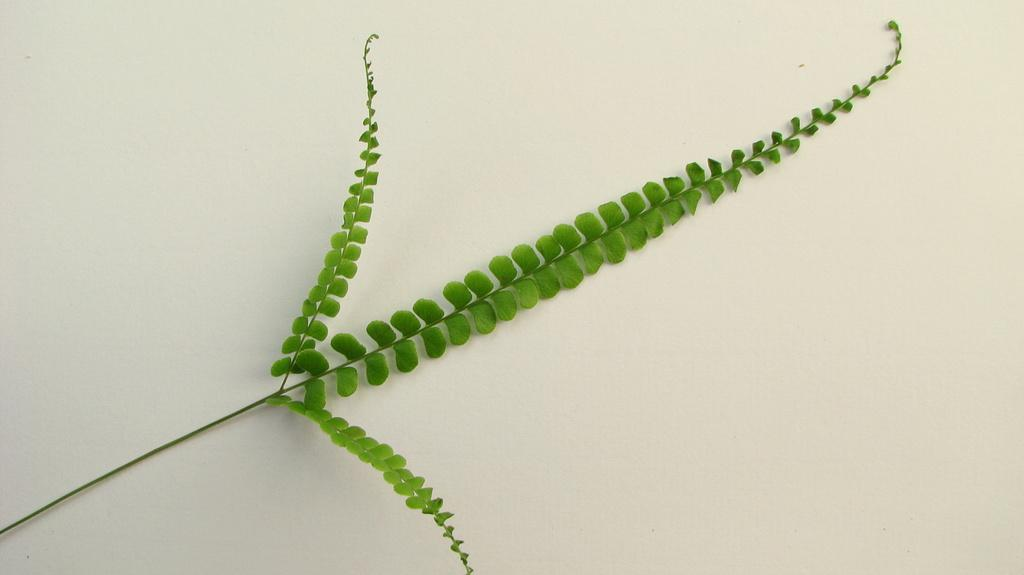What type of vegetation can be seen in the image? There are leaves in the image. What color are the leaves? The leaves are green in color. What is the color of the background in the image? The background of the image is white. Can you tell me the name of the person touching the leaves in the image? There is no person touching the leaves in the image; it only shows leaves and a white background. 